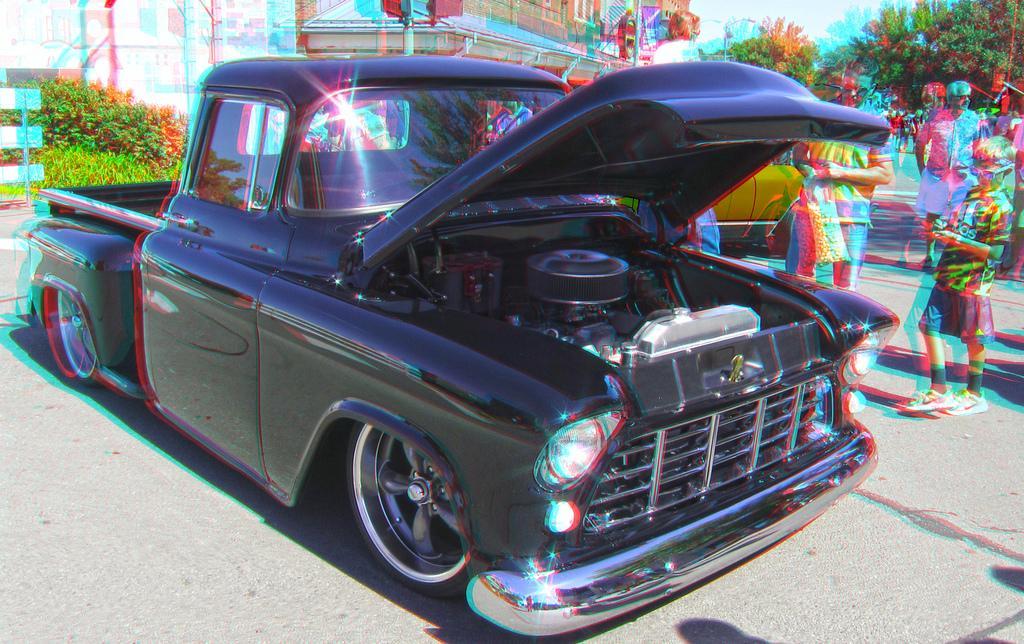Describe this image in one or two sentences. This is an edited image, we can see vehicles on the path and on the right side of the vehicles there are some people standing. Behind the people there are poles, buildings, trees and the sky. 